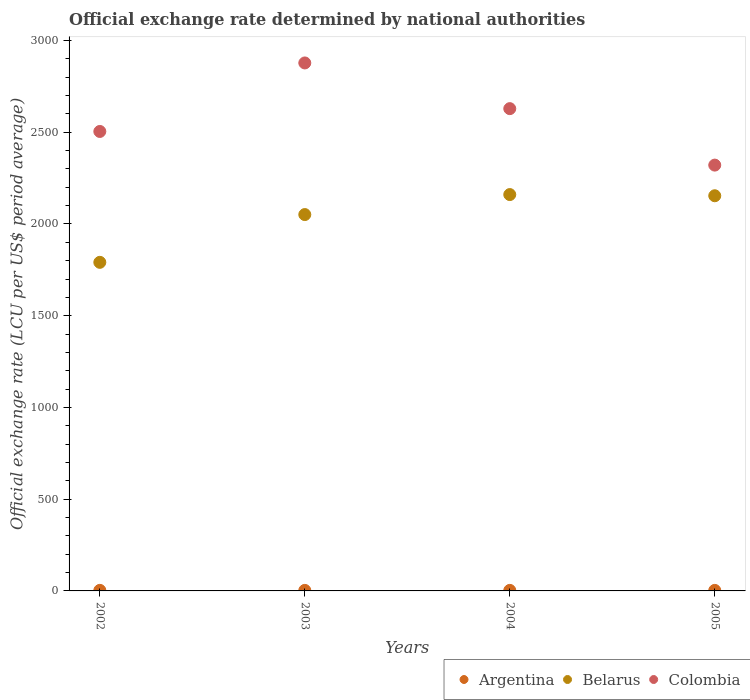Is the number of dotlines equal to the number of legend labels?
Your response must be concise. Yes. What is the official exchange rate in Belarus in 2005?
Keep it short and to the point. 2153.82. Across all years, what is the maximum official exchange rate in Argentina?
Your answer should be very brief. 3.06. Across all years, what is the minimum official exchange rate in Belarus?
Offer a very short reply. 1790.92. In which year was the official exchange rate in Argentina minimum?
Provide a short and direct response. 2003. What is the total official exchange rate in Belarus in the graph?
Your answer should be very brief. 8156.26. What is the difference between the official exchange rate in Belarus in 2003 and that in 2005?
Your answer should be very brief. -102.55. What is the difference between the official exchange rate in Argentina in 2004 and the official exchange rate in Colombia in 2002?
Your response must be concise. -2501.32. What is the average official exchange rate in Colombia per year?
Offer a terse response. 2582.84. In the year 2003, what is the difference between the official exchange rate in Argentina and official exchange rate in Belarus?
Your answer should be compact. -2048.37. In how many years, is the official exchange rate in Argentina greater than 2000 LCU?
Provide a short and direct response. 0. What is the ratio of the official exchange rate in Belarus in 2002 to that in 2004?
Offer a very short reply. 0.83. What is the difference between the highest and the second highest official exchange rate in Argentina?
Provide a succinct answer. 0.14. What is the difference between the highest and the lowest official exchange rate in Belarus?
Provide a succinct answer. 369.34. Is the sum of the official exchange rate in Argentina in 2002 and 2004 greater than the maximum official exchange rate in Colombia across all years?
Give a very brief answer. No. Does the official exchange rate in Argentina monotonically increase over the years?
Make the answer very short. No. How many dotlines are there?
Provide a succinct answer. 3. How many years are there in the graph?
Give a very brief answer. 4. Does the graph contain grids?
Keep it short and to the point. No. Where does the legend appear in the graph?
Offer a very short reply. Bottom right. How are the legend labels stacked?
Your answer should be compact. Horizontal. What is the title of the graph?
Your response must be concise. Official exchange rate determined by national authorities. What is the label or title of the Y-axis?
Ensure brevity in your answer.  Official exchange rate (LCU per US$ period average). What is the Official exchange rate (LCU per US$ period average) of Argentina in 2002?
Keep it short and to the point. 3.06. What is the Official exchange rate (LCU per US$ period average) of Belarus in 2002?
Provide a succinct answer. 1790.92. What is the Official exchange rate (LCU per US$ period average) of Colombia in 2002?
Ensure brevity in your answer.  2504.24. What is the Official exchange rate (LCU per US$ period average) of Argentina in 2003?
Your answer should be compact. 2.9. What is the Official exchange rate (LCU per US$ period average) of Belarus in 2003?
Provide a short and direct response. 2051.27. What is the Official exchange rate (LCU per US$ period average) in Colombia in 2003?
Offer a terse response. 2877.65. What is the Official exchange rate (LCU per US$ period average) in Argentina in 2004?
Offer a very short reply. 2.92. What is the Official exchange rate (LCU per US$ period average) of Belarus in 2004?
Your answer should be very brief. 2160.26. What is the Official exchange rate (LCU per US$ period average) in Colombia in 2004?
Make the answer very short. 2628.61. What is the Official exchange rate (LCU per US$ period average) in Argentina in 2005?
Offer a terse response. 2.9. What is the Official exchange rate (LCU per US$ period average) in Belarus in 2005?
Ensure brevity in your answer.  2153.82. What is the Official exchange rate (LCU per US$ period average) in Colombia in 2005?
Make the answer very short. 2320.83. Across all years, what is the maximum Official exchange rate (LCU per US$ period average) of Argentina?
Provide a short and direct response. 3.06. Across all years, what is the maximum Official exchange rate (LCU per US$ period average) of Belarus?
Provide a succinct answer. 2160.26. Across all years, what is the maximum Official exchange rate (LCU per US$ period average) in Colombia?
Provide a short and direct response. 2877.65. Across all years, what is the minimum Official exchange rate (LCU per US$ period average) in Argentina?
Your answer should be compact. 2.9. Across all years, what is the minimum Official exchange rate (LCU per US$ period average) of Belarus?
Offer a very short reply. 1790.92. Across all years, what is the minimum Official exchange rate (LCU per US$ period average) of Colombia?
Give a very brief answer. 2320.83. What is the total Official exchange rate (LCU per US$ period average) in Argentina in the graph?
Provide a short and direct response. 11.79. What is the total Official exchange rate (LCU per US$ period average) in Belarus in the graph?
Give a very brief answer. 8156.27. What is the total Official exchange rate (LCU per US$ period average) of Colombia in the graph?
Provide a short and direct response. 1.03e+04. What is the difference between the Official exchange rate (LCU per US$ period average) of Argentina in 2002 and that in 2003?
Keep it short and to the point. 0.16. What is the difference between the Official exchange rate (LCU per US$ period average) of Belarus in 2002 and that in 2003?
Make the answer very short. -260.35. What is the difference between the Official exchange rate (LCU per US$ period average) in Colombia in 2002 and that in 2003?
Ensure brevity in your answer.  -373.41. What is the difference between the Official exchange rate (LCU per US$ period average) in Argentina in 2002 and that in 2004?
Offer a very short reply. 0.14. What is the difference between the Official exchange rate (LCU per US$ period average) in Belarus in 2002 and that in 2004?
Your answer should be very brief. -369.34. What is the difference between the Official exchange rate (LCU per US$ period average) in Colombia in 2002 and that in 2004?
Provide a succinct answer. -124.37. What is the difference between the Official exchange rate (LCU per US$ period average) in Argentina in 2002 and that in 2005?
Offer a very short reply. 0.16. What is the difference between the Official exchange rate (LCU per US$ period average) in Belarus in 2002 and that in 2005?
Your answer should be very brief. -362.9. What is the difference between the Official exchange rate (LCU per US$ period average) of Colombia in 2002 and that in 2005?
Keep it short and to the point. 183.41. What is the difference between the Official exchange rate (LCU per US$ period average) of Argentina in 2003 and that in 2004?
Your response must be concise. -0.02. What is the difference between the Official exchange rate (LCU per US$ period average) of Belarus in 2003 and that in 2004?
Provide a succinct answer. -108.99. What is the difference between the Official exchange rate (LCU per US$ period average) of Colombia in 2003 and that in 2004?
Your answer should be very brief. 249.04. What is the difference between the Official exchange rate (LCU per US$ period average) in Argentina in 2003 and that in 2005?
Provide a succinct answer. -0. What is the difference between the Official exchange rate (LCU per US$ period average) in Belarus in 2003 and that in 2005?
Offer a terse response. -102.55. What is the difference between the Official exchange rate (LCU per US$ period average) in Colombia in 2003 and that in 2005?
Provide a short and direct response. 556.82. What is the difference between the Official exchange rate (LCU per US$ period average) in Argentina in 2004 and that in 2005?
Your answer should be compact. 0.02. What is the difference between the Official exchange rate (LCU per US$ period average) of Belarus in 2004 and that in 2005?
Make the answer very short. 6.44. What is the difference between the Official exchange rate (LCU per US$ period average) of Colombia in 2004 and that in 2005?
Offer a terse response. 307.78. What is the difference between the Official exchange rate (LCU per US$ period average) of Argentina in 2002 and the Official exchange rate (LCU per US$ period average) of Belarus in 2003?
Offer a very short reply. -2048.21. What is the difference between the Official exchange rate (LCU per US$ period average) of Argentina in 2002 and the Official exchange rate (LCU per US$ period average) of Colombia in 2003?
Provide a short and direct response. -2874.59. What is the difference between the Official exchange rate (LCU per US$ period average) in Belarus in 2002 and the Official exchange rate (LCU per US$ period average) in Colombia in 2003?
Your answer should be very brief. -1086.74. What is the difference between the Official exchange rate (LCU per US$ period average) of Argentina in 2002 and the Official exchange rate (LCU per US$ period average) of Belarus in 2004?
Make the answer very short. -2157.19. What is the difference between the Official exchange rate (LCU per US$ period average) in Argentina in 2002 and the Official exchange rate (LCU per US$ period average) in Colombia in 2004?
Offer a very short reply. -2625.55. What is the difference between the Official exchange rate (LCU per US$ period average) of Belarus in 2002 and the Official exchange rate (LCU per US$ period average) of Colombia in 2004?
Make the answer very short. -837.7. What is the difference between the Official exchange rate (LCU per US$ period average) in Argentina in 2002 and the Official exchange rate (LCU per US$ period average) in Belarus in 2005?
Provide a short and direct response. -2150.76. What is the difference between the Official exchange rate (LCU per US$ period average) of Argentina in 2002 and the Official exchange rate (LCU per US$ period average) of Colombia in 2005?
Your answer should be compact. -2317.77. What is the difference between the Official exchange rate (LCU per US$ period average) of Belarus in 2002 and the Official exchange rate (LCU per US$ period average) of Colombia in 2005?
Ensure brevity in your answer.  -529.92. What is the difference between the Official exchange rate (LCU per US$ period average) in Argentina in 2003 and the Official exchange rate (LCU per US$ period average) in Belarus in 2004?
Offer a terse response. -2157.36. What is the difference between the Official exchange rate (LCU per US$ period average) in Argentina in 2003 and the Official exchange rate (LCU per US$ period average) in Colombia in 2004?
Offer a very short reply. -2625.71. What is the difference between the Official exchange rate (LCU per US$ period average) in Belarus in 2003 and the Official exchange rate (LCU per US$ period average) in Colombia in 2004?
Keep it short and to the point. -577.34. What is the difference between the Official exchange rate (LCU per US$ period average) in Argentina in 2003 and the Official exchange rate (LCU per US$ period average) in Belarus in 2005?
Provide a succinct answer. -2150.92. What is the difference between the Official exchange rate (LCU per US$ period average) of Argentina in 2003 and the Official exchange rate (LCU per US$ period average) of Colombia in 2005?
Give a very brief answer. -2317.93. What is the difference between the Official exchange rate (LCU per US$ period average) in Belarus in 2003 and the Official exchange rate (LCU per US$ period average) in Colombia in 2005?
Offer a very short reply. -269.56. What is the difference between the Official exchange rate (LCU per US$ period average) in Argentina in 2004 and the Official exchange rate (LCU per US$ period average) in Belarus in 2005?
Provide a short and direct response. -2150.9. What is the difference between the Official exchange rate (LCU per US$ period average) in Argentina in 2004 and the Official exchange rate (LCU per US$ period average) in Colombia in 2005?
Provide a succinct answer. -2317.91. What is the difference between the Official exchange rate (LCU per US$ period average) of Belarus in 2004 and the Official exchange rate (LCU per US$ period average) of Colombia in 2005?
Provide a succinct answer. -160.58. What is the average Official exchange rate (LCU per US$ period average) of Argentina per year?
Offer a terse response. 2.95. What is the average Official exchange rate (LCU per US$ period average) in Belarus per year?
Offer a terse response. 2039.07. What is the average Official exchange rate (LCU per US$ period average) in Colombia per year?
Your answer should be compact. 2582.84. In the year 2002, what is the difference between the Official exchange rate (LCU per US$ period average) in Argentina and Official exchange rate (LCU per US$ period average) in Belarus?
Offer a very short reply. -1787.85. In the year 2002, what is the difference between the Official exchange rate (LCU per US$ period average) of Argentina and Official exchange rate (LCU per US$ period average) of Colombia?
Your answer should be compact. -2501.18. In the year 2002, what is the difference between the Official exchange rate (LCU per US$ period average) in Belarus and Official exchange rate (LCU per US$ period average) in Colombia?
Your response must be concise. -713.32. In the year 2003, what is the difference between the Official exchange rate (LCU per US$ period average) in Argentina and Official exchange rate (LCU per US$ period average) in Belarus?
Offer a terse response. -2048.37. In the year 2003, what is the difference between the Official exchange rate (LCU per US$ period average) in Argentina and Official exchange rate (LCU per US$ period average) in Colombia?
Your response must be concise. -2874.75. In the year 2003, what is the difference between the Official exchange rate (LCU per US$ period average) in Belarus and Official exchange rate (LCU per US$ period average) in Colombia?
Make the answer very short. -826.38. In the year 2004, what is the difference between the Official exchange rate (LCU per US$ period average) of Argentina and Official exchange rate (LCU per US$ period average) of Belarus?
Offer a terse response. -2157.33. In the year 2004, what is the difference between the Official exchange rate (LCU per US$ period average) in Argentina and Official exchange rate (LCU per US$ period average) in Colombia?
Give a very brief answer. -2625.69. In the year 2004, what is the difference between the Official exchange rate (LCU per US$ period average) of Belarus and Official exchange rate (LCU per US$ period average) of Colombia?
Your response must be concise. -468.36. In the year 2005, what is the difference between the Official exchange rate (LCU per US$ period average) in Argentina and Official exchange rate (LCU per US$ period average) in Belarus?
Ensure brevity in your answer.  -2150.92. In the year 2005, what is the difference between the Official exchange rate (LCU per US$ period average) of Argentina and Official exchange rate (LCU per US$ period average) of Colombia?
Keep it short and to the point. -2317.93. In the year 2005, what is the difference between the Official exchange rate (LCU per US$ period average) of Belarus and Official exchange rate (LCU per US$ period average) of Colombia?
Ensure brevity in your answer.  -167.01. What is the ratio of the Official exchange rate (LCU per US$ period average) in Argentina in 2002 to that in 2003?
Provide a short and direct response. 1.06. What is the ratio of the Official exchange rate (LCU per US$ period average) in Belarus in 2002 to that in 2003?
Your response must be concise. 0.87. What is the ratio of the Official exchange rate (LCU per US$ period average) of Colombia in 2002 to that in 2003?
Your answer should be compact. 0.87. What is the ratio of the Official exchange rate (LCU per US$ period average) of Argentina in 2002 to that in 2004?
Make the answer very short. 1.05. What is the ratio of the Official exchange rate (LCU per US$ period average) of Belarus in 2002 to that in 2004?
Offer a very short reply. 0.83. What is the ratio of the Official exchange rate (LCU per US$ period average) of Colombia in 2002 to that in 2004?
Give a very brief answer. 0.95. What is the ratio of the Official exchange rate (LCU per US$ period average) in Argentina in 2002 to that in 2005?
Your response must be concise. 1.05. What is the ratio of the Official exchange rate (LCU per US$ period average) in Belarus in 2002 to that in 2005?
Give a very brief answer. 0.83. What is the ratio of the Official exchange rate (LCU per US$ period average) in Colombia in 2002 to that in 2005?
Your answer should be compact. 1.08. What is the ratio of the Official exchange rate (LCU per US$ period average) in Belarus in 2003 to that in 2004?
Provide a short and direct response. 0.95. What is the ratio of the Official exchange rate (LCU per US$ period average) in Colombia in 2003 to that in 2004?
Provide a succinct answer. 1.09. What is the ratio of the Official exchange rate (LCU per US$ period average) of Argentina in 2003 to that in 2005?
Make the answer very short. 1. What is the ratio of the Official exchange rate (LCU per US$ period average) of Colombia in 2003 to that in 2005?
Provide a short and direct response. 1.24. What is the ratio of the Official exchange rate (LCU per US$ period average) of Argentina in 2004 to that in 2005?
Offer a terse response. 1.01. What is the ratio of the Official exchange rate (LCU per US$ period average) of Colombia in 2004 to that in 2005?
Offer a terse response. 1.13. What is the difference between the highest and the second highest Official exchange rate (LCU per US$ period average) in Argentina?
Provide a succinct answer. 0.14. What is the difference between the highest and the second highest Official exchange rate (LCU per US$ period average) of Belarus?
Your response must be concise. 6.44. What is the difference between the highest and the second highest Official exchange rate (LCU per US$ period average) in Colombia?
Provide a short and direct response. 249.04. What is the difference between the highest and the lowest Official exchange rate (LCU per US$ period average) in Argentina?
Provide a succinct answer. 0.16. What is the difference between the highest and the lowest Official exchange rate (LCU per US$ period average) of Belarus?
Offer a very short reply. 369.34. What is the difference between the highest and the lowest Official exchange rate (LCU per US$ period average) in Colombia?
Offer a terse response. 556.82. 